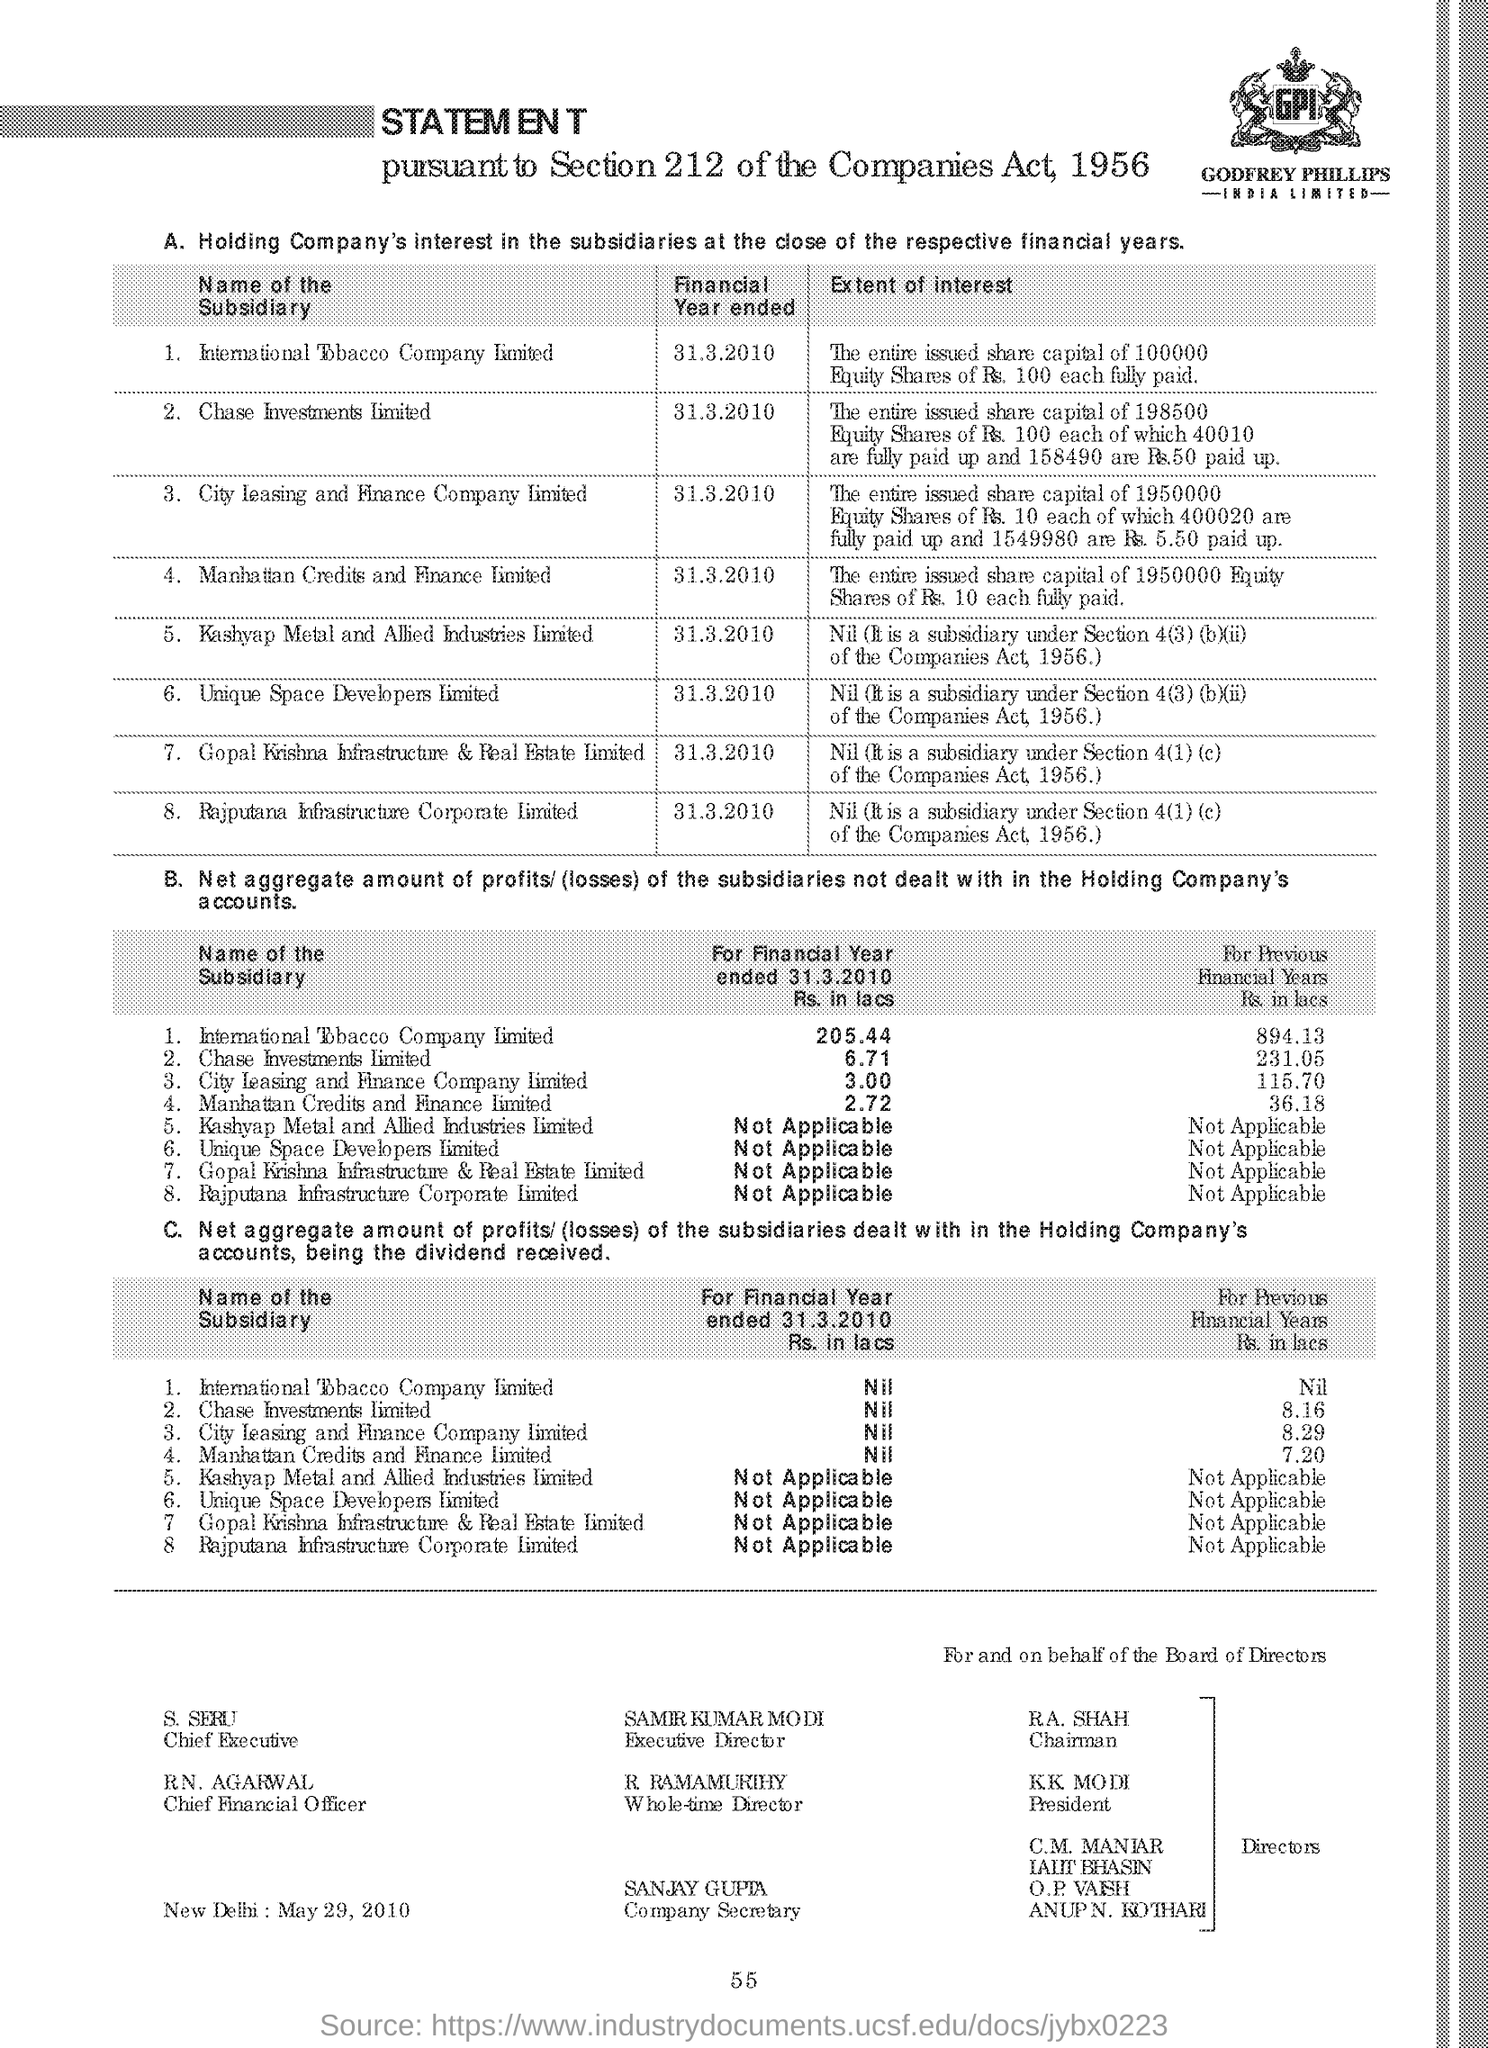Specify some key components in this picture. The current president of the country is K.K. Modi. R.A. Shah is the chairman. R.N. Agarwal is the chief financial officer. The financial year for the International Tobacco Company ended on March 31, 2010. The person who is the whole time director is R. Ramamurthy. 